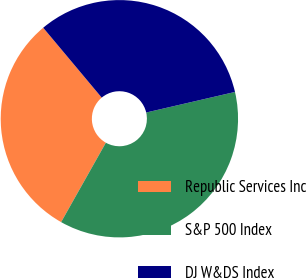Convert chart. <chart><loc_0><loc_0><loc_500><loc_500><pie_chart><fcel>Republic Services Inc<fcel>S&P 500 Index<fcel>DJ W&DS Index<nl><fcel>30.74%<fcel>36.79%<fcel>32.47%<nl></chart> 